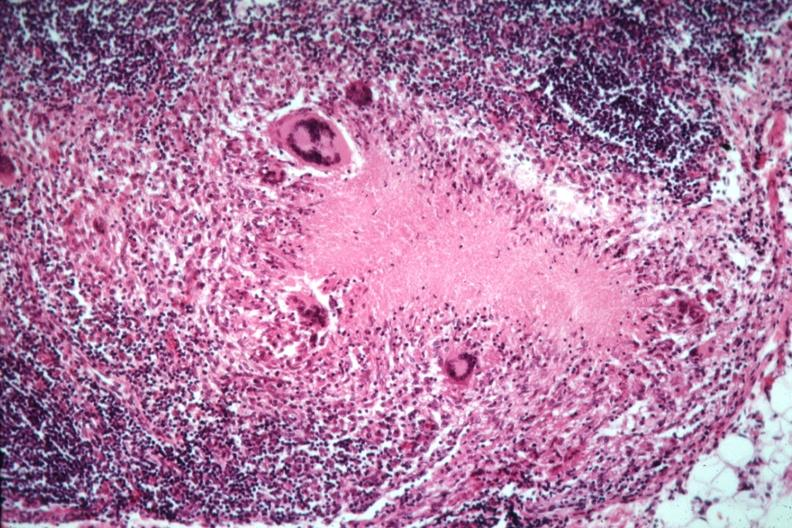s this section present?
Answer the question using a single word or phrase. No 